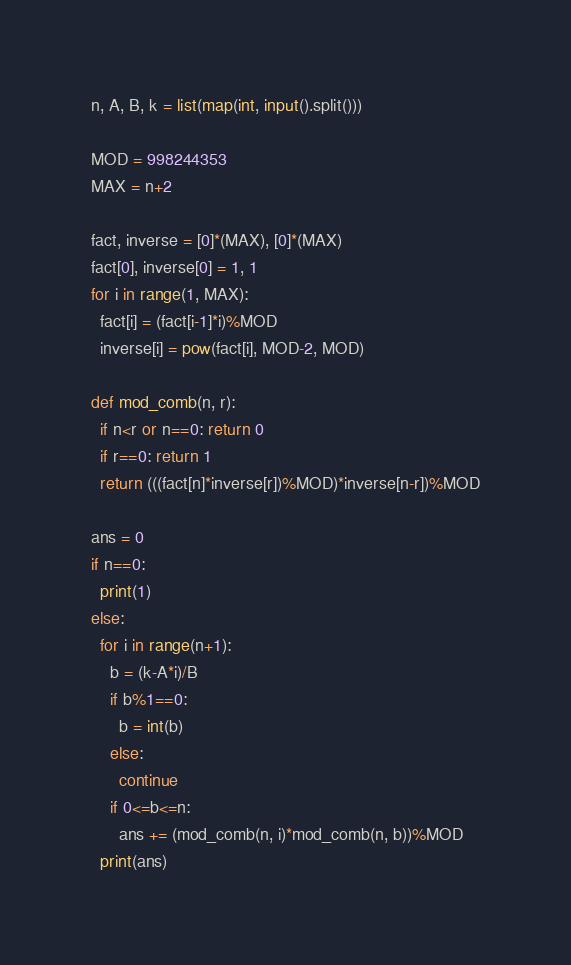Convert code to text. <code><loc_0><loc_0><loc_500><loc_500><_Python_>n, A, B, k = list(map(int, input().split()))

MOD = 998244353
MAX = n+2

fact, inverse = [0]*(MAX), [0]*(MAX)
fact[0], inverse[0] = 1, 1
for i in range(1, MAX):
  fact[i] = (fact[i-1]*i)%MOD
  inverse[i] = pow(fact[i], MOD-2, MOD)

def mod_comb(n, r):
  if n<r or n==0: return 0
  if r==0: return 1
  return (((fact[n]*inverse[r])%MOD)*inverse[n-r])%MOD

ans = 0
if n==0:
  print(1)
else:
  for i in range(n+1):
    b = (k-A*i)/B
    if b%1==0:
      b = int(b)
    else:
      continue
    if 0<=b<=n:
      ans += (mod_comb(n, i)*mod_comb(n, b))%MOD
  print(ans)</code> 